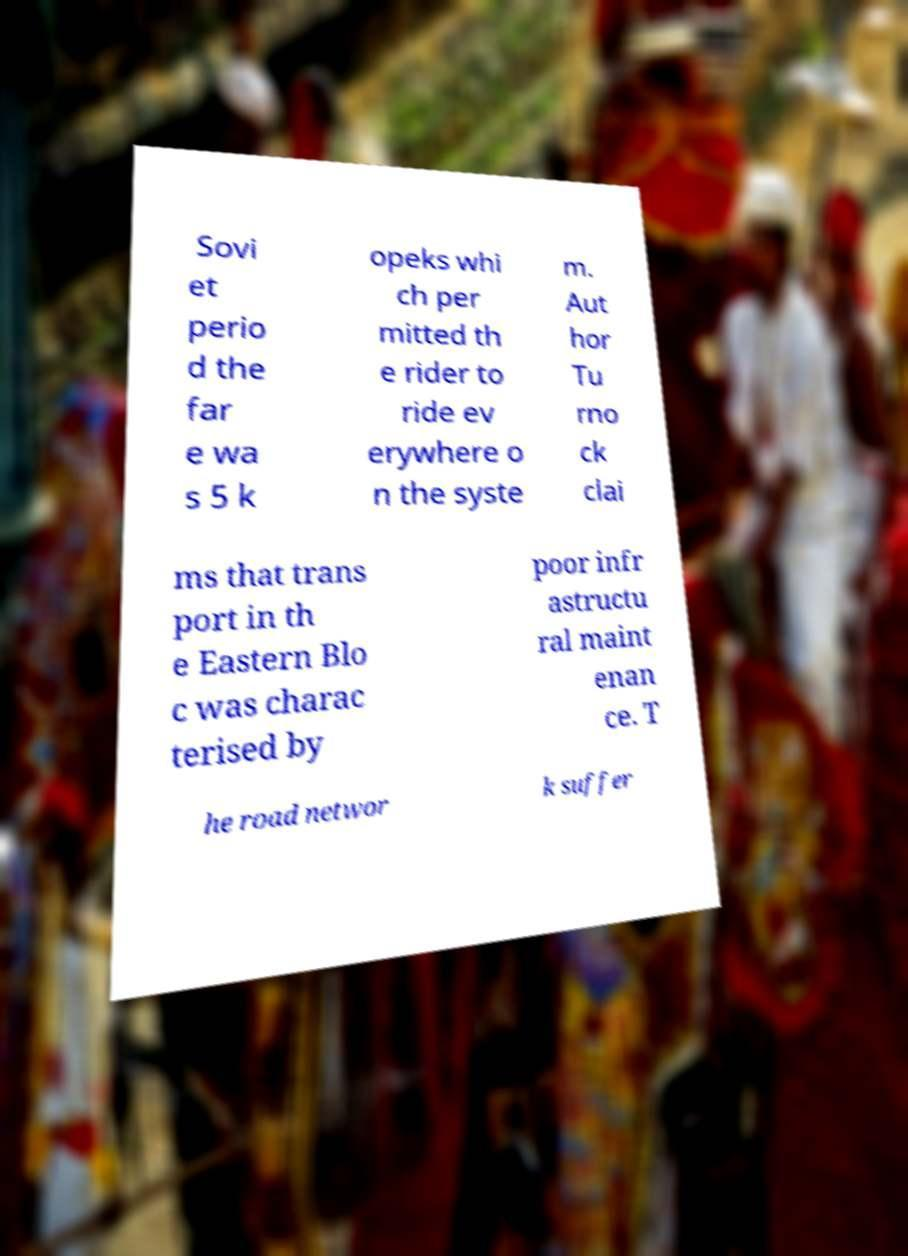Could you assist in decoding the text presented in this image and type it out clearly? Sovi et perio d the far e wa s 5 k opeks whi ch per mitted th e rider to ride ev erywhere o n the syste m. Aut hor Tu rno ck clai ms that trans port in th e Eastern Blo c was charac terised by poor infr astructu ral maint enan ce. T he road networ k suffer 